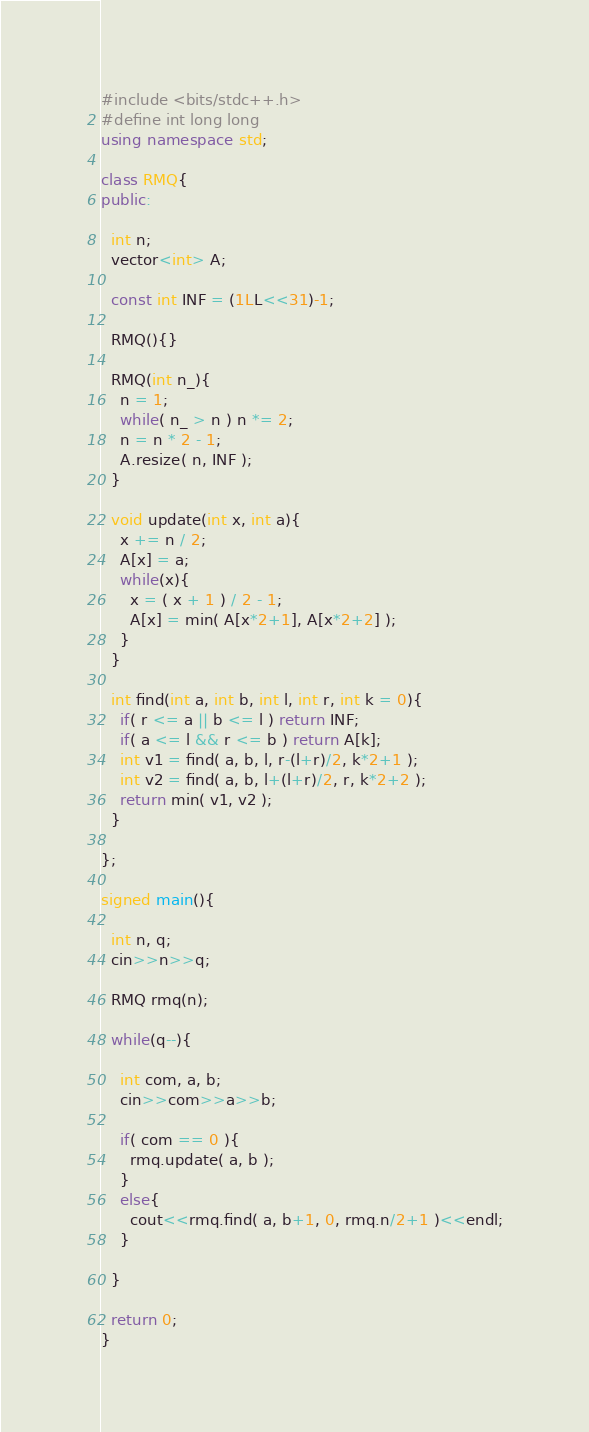<code> <loc_0><loc_0><loc_500><loc_500><_C++_>#include <bits/stdc++.h>
#define int long long
using namespace std;

class RMQ{
public:
  
  int n;
  vector<int> A;
  
  const int INF = (1LL<<31)-1;
  
  RMQ(){}

  RMQ(int n_){
    n = 1;
    while( n_ > n ) n *= 2;
    n = n * 2 - 1;
    A.resize( n, INF );
  }
  
  void update(int x, int a){
    x += n / 2;
    A[x] = a;
    while(x){
      x = ( x + 1 ) / 2 - 1;
      A[x] = min( A[x*2+1], A[x*2+2] );
    }
  }
  
  int find(int a, int b, int l, int r, int k = 0){
    if( r <= a || b <= l ) return INF;
    if( a <= l && r <= b ) return A[k];
    int v1 = find( a, b, l, r-(l+r)/2, k*2+1 );
    int v2 = find( a, b, l+(l+r)/2, r, k*2+2 );
    return min( v1, v2 );
  }
  
};

signed main(){
  
  int n, q;
  cin>>n>>q;
  
  RMQ rmq(n);
    
  while(q--){
    
    int com, a, b;
    cin>>com>>a>>b;
    
    if( com == 0 ){
      rmq.update( a, b );
    }
    else{
      cout<<rmq.find( a, b+1, 0, rmq.n/2+1 )<<endl;
    }
    
  }
  
  return 0;
}

</code> 